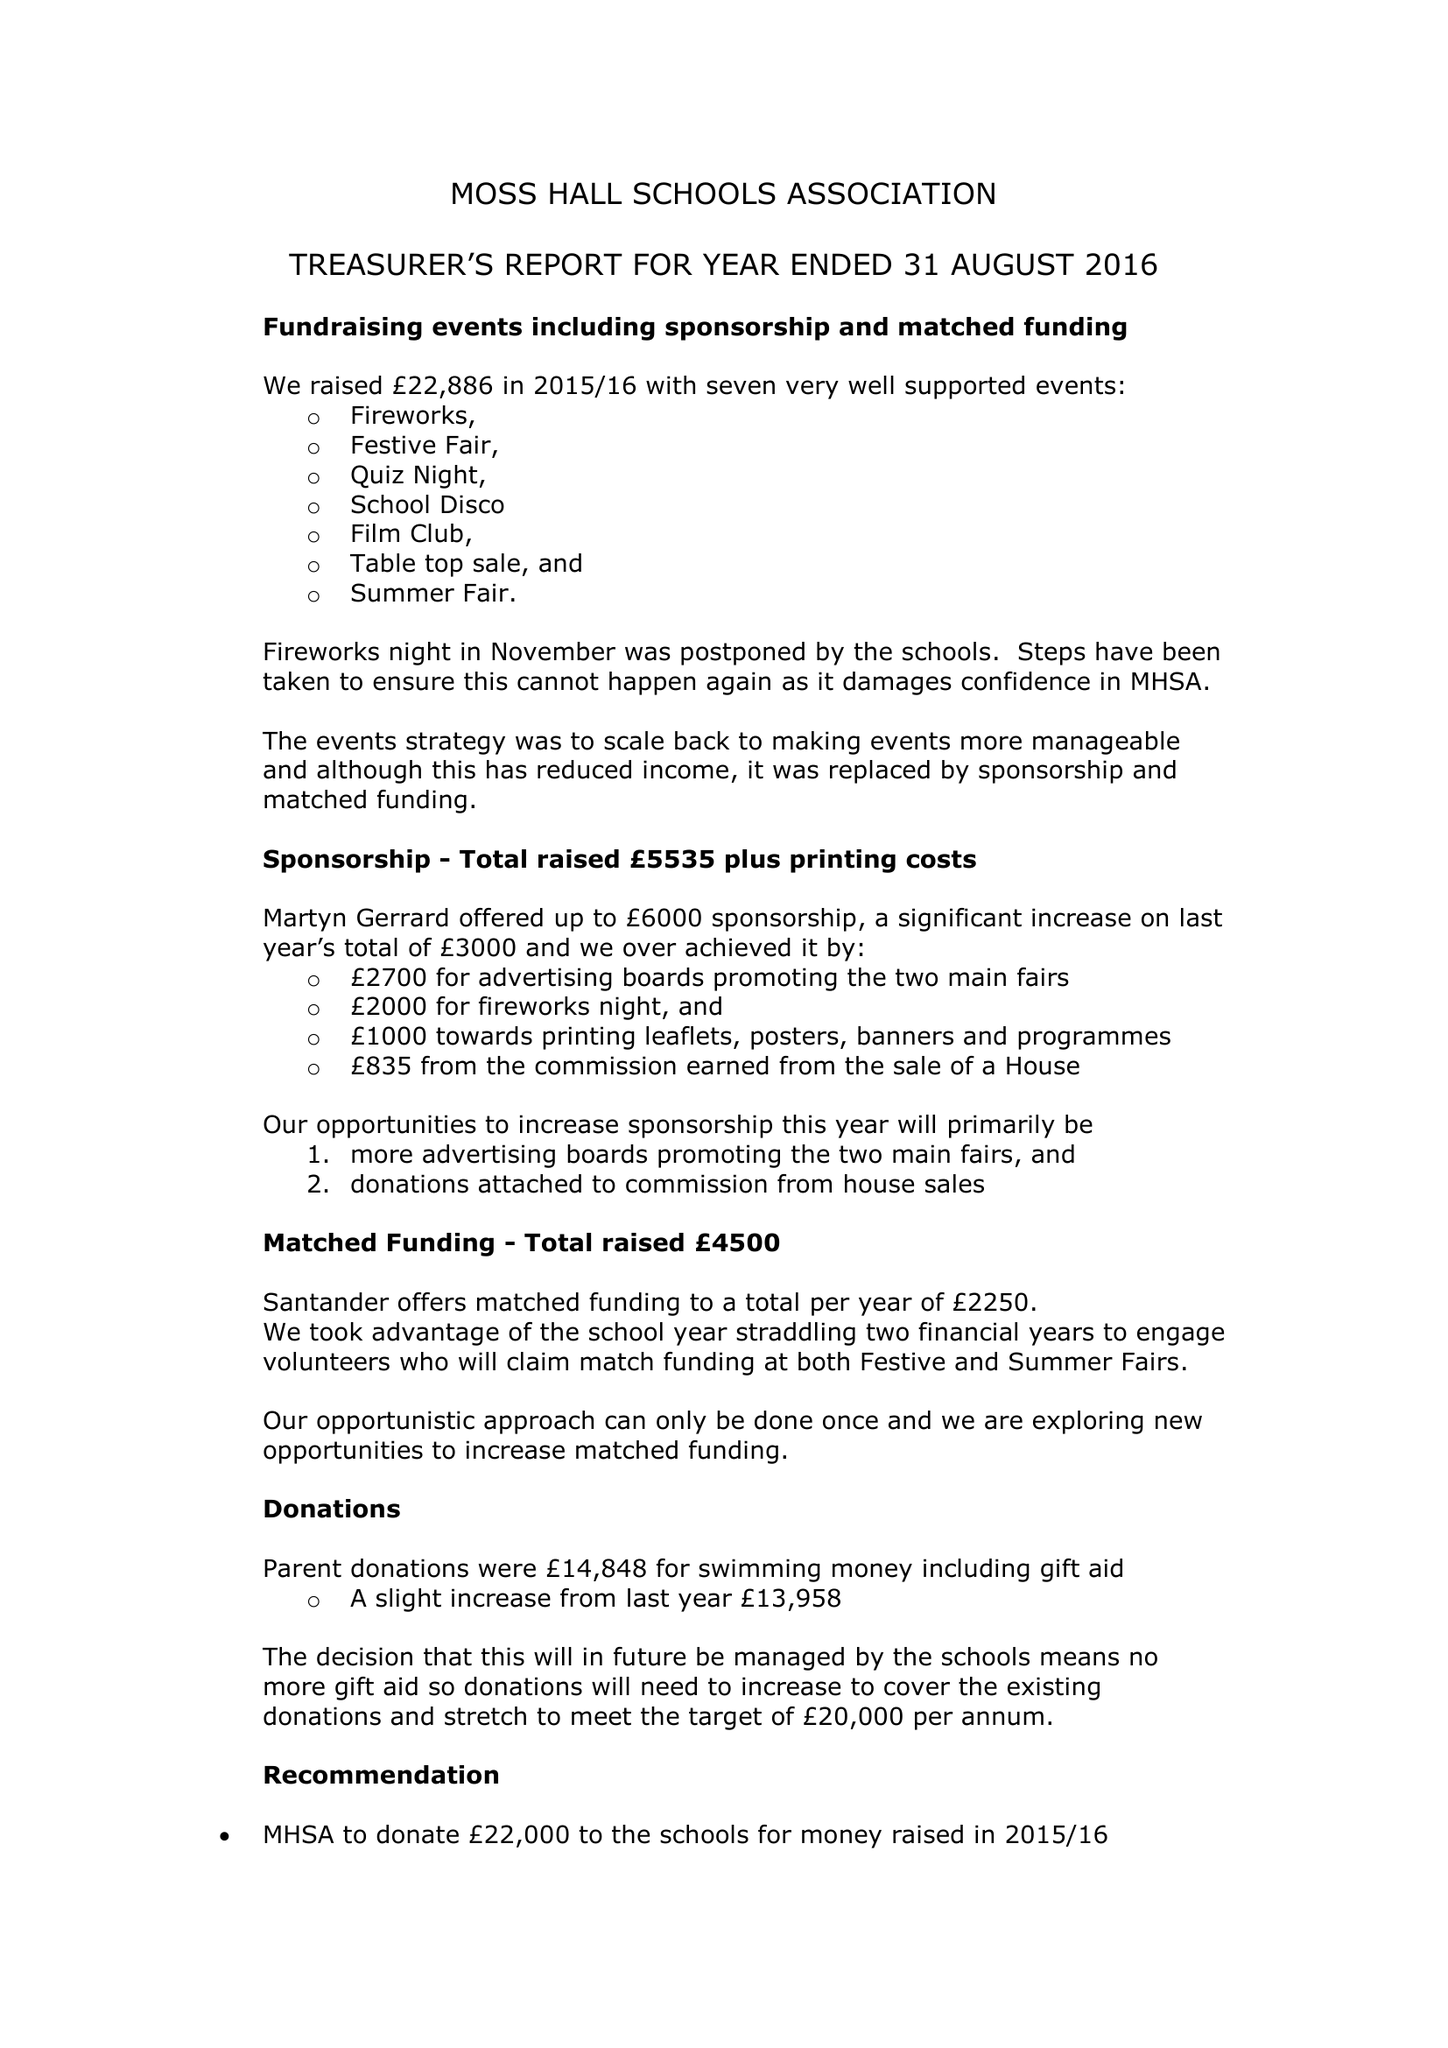What is the value for the report_date?
Answer the question using a single word or phrase. 2016-08-31 